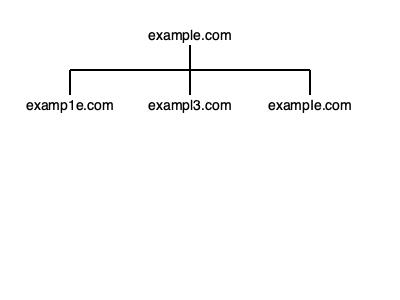Given the domain tree diagram above, which of the displayed domain names is most likely to be used in a typosquatting attack against the legitimate domain "example.com"? To identify the domain name most likely to be used in a typosquatting attack, we need to analyze each variation and consider how easily it could be mistaken for the legitimate domain:

1. examp1e.com: This domain replaces the lowercase "l" with the number "1". While visually similar, the use of a number is more noticeable and less likely to be accidentally typed.

2. exampl3.com: This domain replaces the "e" at the end with the number "3". This change is more obvious and less likely to be mistaken for the original domain.

3. exampIe.com: This domain replaces the lowercase "l" with an uppercase "I" (capital i). This is the most subtle change, as in many fonts, a lowercase "l" and an uppercase "I" look nearly identical.

The goal of typosquatting is to create a domain that is as visually similar to the original as possible, increasing the likelihood of users accidentally visiting the wrong site. Among the given options, exampIe.com achieves this goal most effectively.
Answer: exampIe.com 